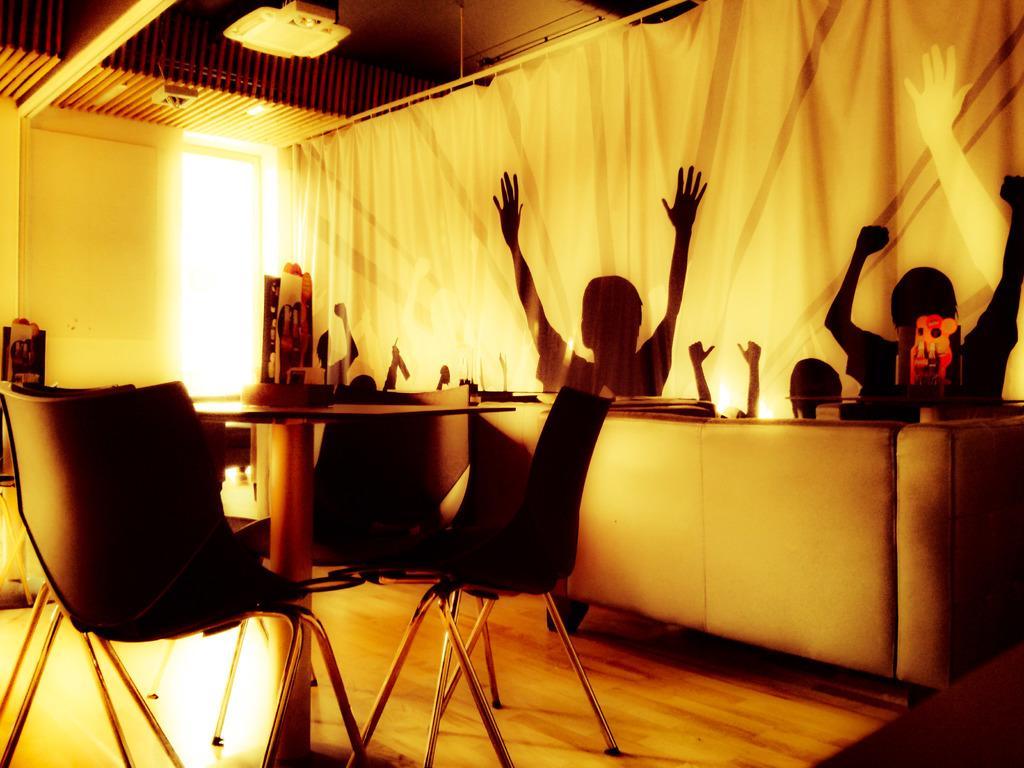Please provide a concise description of this image. In this image I can see few chairs, a table and a sofa. I can also see few stuffs on this table. 